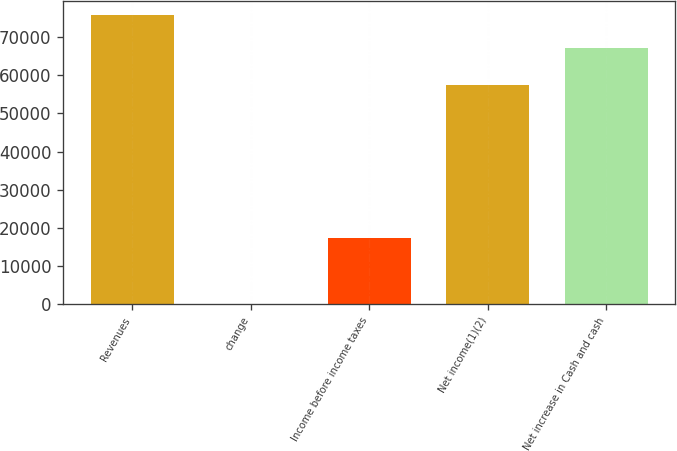Convert chart. <chart><loc_0><loc_0><loc_500><loc_500><bar_chart><fcel>Revenues<fcel>change<fcel>Income before income taxes<fcel>Net income(1)(2)<fcel>Net increase in Cash and cash<nl><fcel>75797<fcel>29.7<fcel>17316<fcel>57587<fcel>67267<nl></chart> 